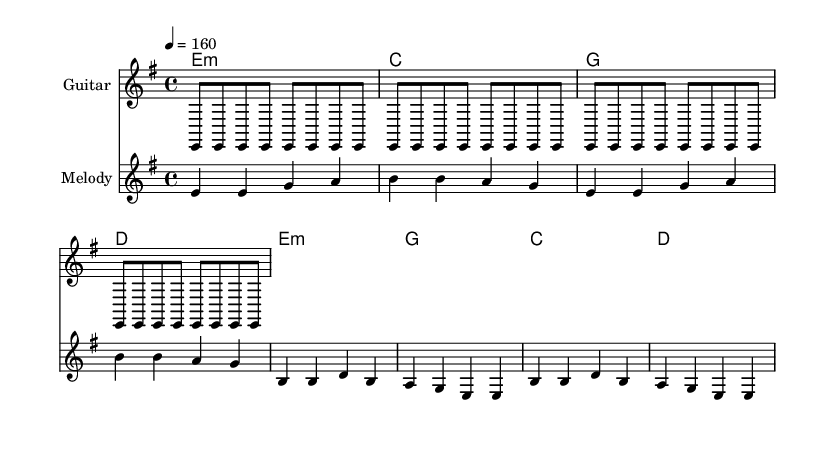What is the key signature of this music? The key signature is indicated by the sharp or flat symbols at the beginning of the staff. In this case, there are no sharps or flats, indicating it is in E minor.
Answer: E minor What is the time signature of this music? The time signature is located at the beginning of the score, represented as a fraction. Here, it shows a four on top and a four on the bottom, meaning there are four beats in a measure.
Answer: 4/4 What is the tempo of this piece? The tempo is stated in beats per minute at the beginning, shown as a number followed by an equal sign. In this case, it indicates 160 beats per minute.
Answer: 160 How many measures are in the verse? To find the number of measures in the verse, count the distinct groupings between the vertical lines (bar lines) for the verse section. There are four measures in the verse.
Answer: 4 Which chord is used in the chorus? The chorus section lists chord symbols above the melody; each chord can be identified by looking specifically at the chord names above the staff. The first chord in the chorus is E minor.
Answer: E minor What societal issue is addressed in the lyrics? To identify the societal issue, read through the lyrics in the section marked "verse." They talk about hospitals closing and waiting lists growing, which points to issues within the healthcare system.
Answer: Healthcare system What type of musical style does this piece represent? This piece utilizes elements characteristic of punk music, such as a fast tempo, simple chord progressions, and socially conscious lyrics, indicating it is a punk anthem.
Answer: Punk 